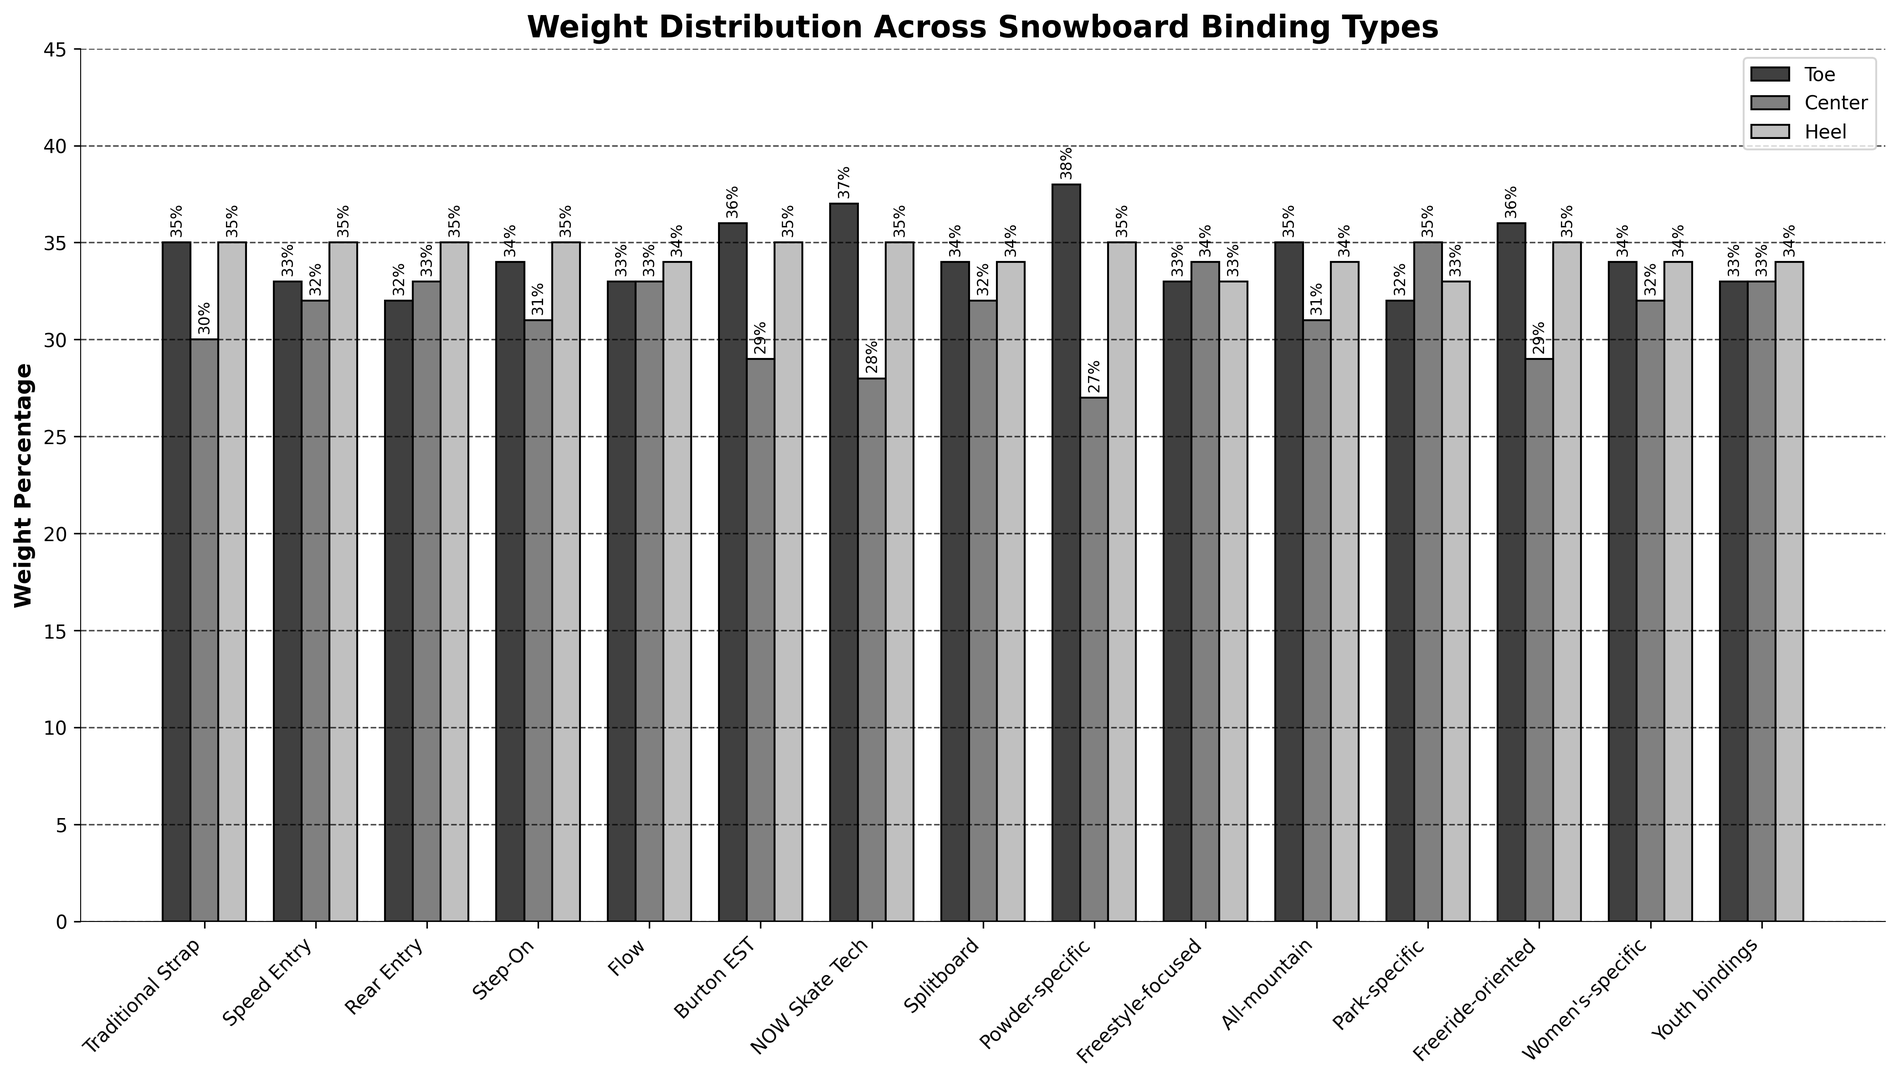Which snowboard binding type has the highest toe weight percentage? The highest toe weight percentage is indicated by the tallest black bar. By visual inspection, this is the "Powder-specific" binding type with 38%.
Answer: Powder-specific Which snowboard binding types have the same heel weight percentage? The bars all have the same height in the heel weight category (light gray). Many of them have the same height at 35%, which includes: Traditional Strap, Speed Entry, Rear Entry, Step-On, Burton EST, NOW Skate Tech, Powder-specific, Freeride-oriented.
Answer: Traditional Strap, Speed Entry, Rear Entry, Step-On, Burton EST, NOW Skate Tech, Powder-specific, Freeride-oriented What is the average center weight percentage for all-mountain and park-specific bindings? For all-mountain, the center weight percentage is 31%. For park-specific, it is 35%. The average is calculated as (31 + 35)/2 = 33.
Answer: 33 Which binding type shows the greatest weight percentage at the center? The tallest dark gray bar represents the center weight percentage. The "Park-specific" binding type shows the highest value with 35%.
Answer: Park-specific Do any binding types have the same weight percentage evenly distributed across toe, center, and heel? Check for binding types where all three bars (black, dark gray, light gray) are the same height. None of the binding types have equal distribution percentages for toe, center, and heel weights.
Answer: No Compare toe and center weight percentages for the "Burton EST" binding type. Which is higher? For "Burton EST," the toe weight percentage is 36% and the center weight percentage is 29%. Toe is higher.
Answer: Toe What is the total weight percentage for the "Youth bindings" type? The total weight is the sum of all bars' heights for "Youth bindings" type: 33% (toe) + 33% (center) + 34% (heel) = 100%.
Answer: 100% Which binding type has the lowest center weight percentage? The shortest dark gray bar represents the lowest center weight. The "Powder-specific" binding type has the lowest value with 27%.
Answer: Powder-specific Which binding types share the same total weight percentage with the "Freestyle-focused" type? The total weight percentage for "Freestyle-focused" is 33% (toe) + 34% (center) + 33% (heel) = 100%. Identical total percentages: "Youth bindings" and "Women's-specific" both have 100%.
Answer: Youth bindings, Women's-specific 